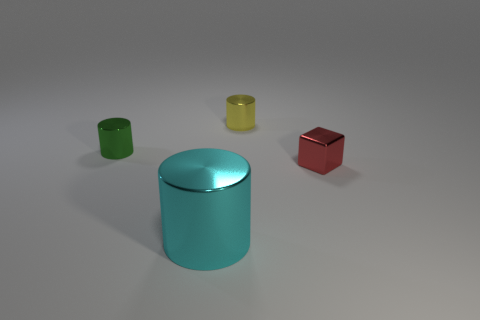Do the red metallic object that is in front of the small yellow metal cylinder and the metallic thing in front of the tiny block have the same shape?
Your response must be concise. No. What color is the metallic cube?
Provide a succinct answer. Red. What number of shiny objects are cyan cylinders or small blue cylinders?
Your answer should be very brief. 1. There is another small metallic object that is the same shape as the small yellow metal thing; what is its color?
Your response must be concise. Green. Are any green rubber cylinders visible?
Offer a very short reply. No. Is the cylinder that is left of the big metallic object made of the same material as the small object to the right of the small yellow thing?
Your answer should be very brief. Yes. What number of things are either cylinders that are in front of the red object or cylinders that are to the left of the big cyan metallic cylinder?
Keep it short and to the point. 2. Does the object in front of the tiny red block have the same color as the small cylinder that is right of the small green thing?
Your response must be concise. No. The metallic thing that is behind the cyan metal thing and on the left side of the yellow metallic cylinder has what shape?
Keep it short and to the point. Cylinder. The block that is the same size as the green metal thing is what color?
Offer a very short reply. Red. 